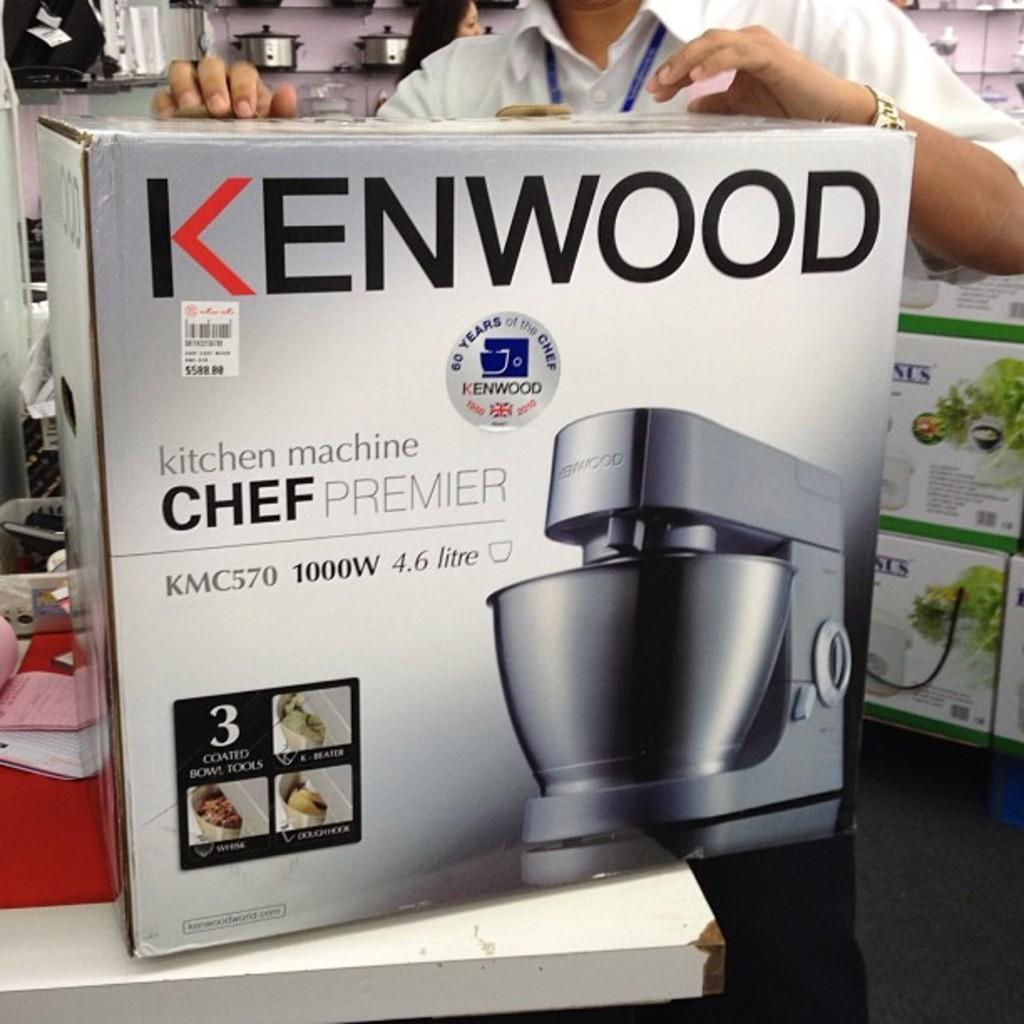<image>
Create a compact narrative representing the image presented. A box with a Kenwood Chef Premier bowl mixer inside. 